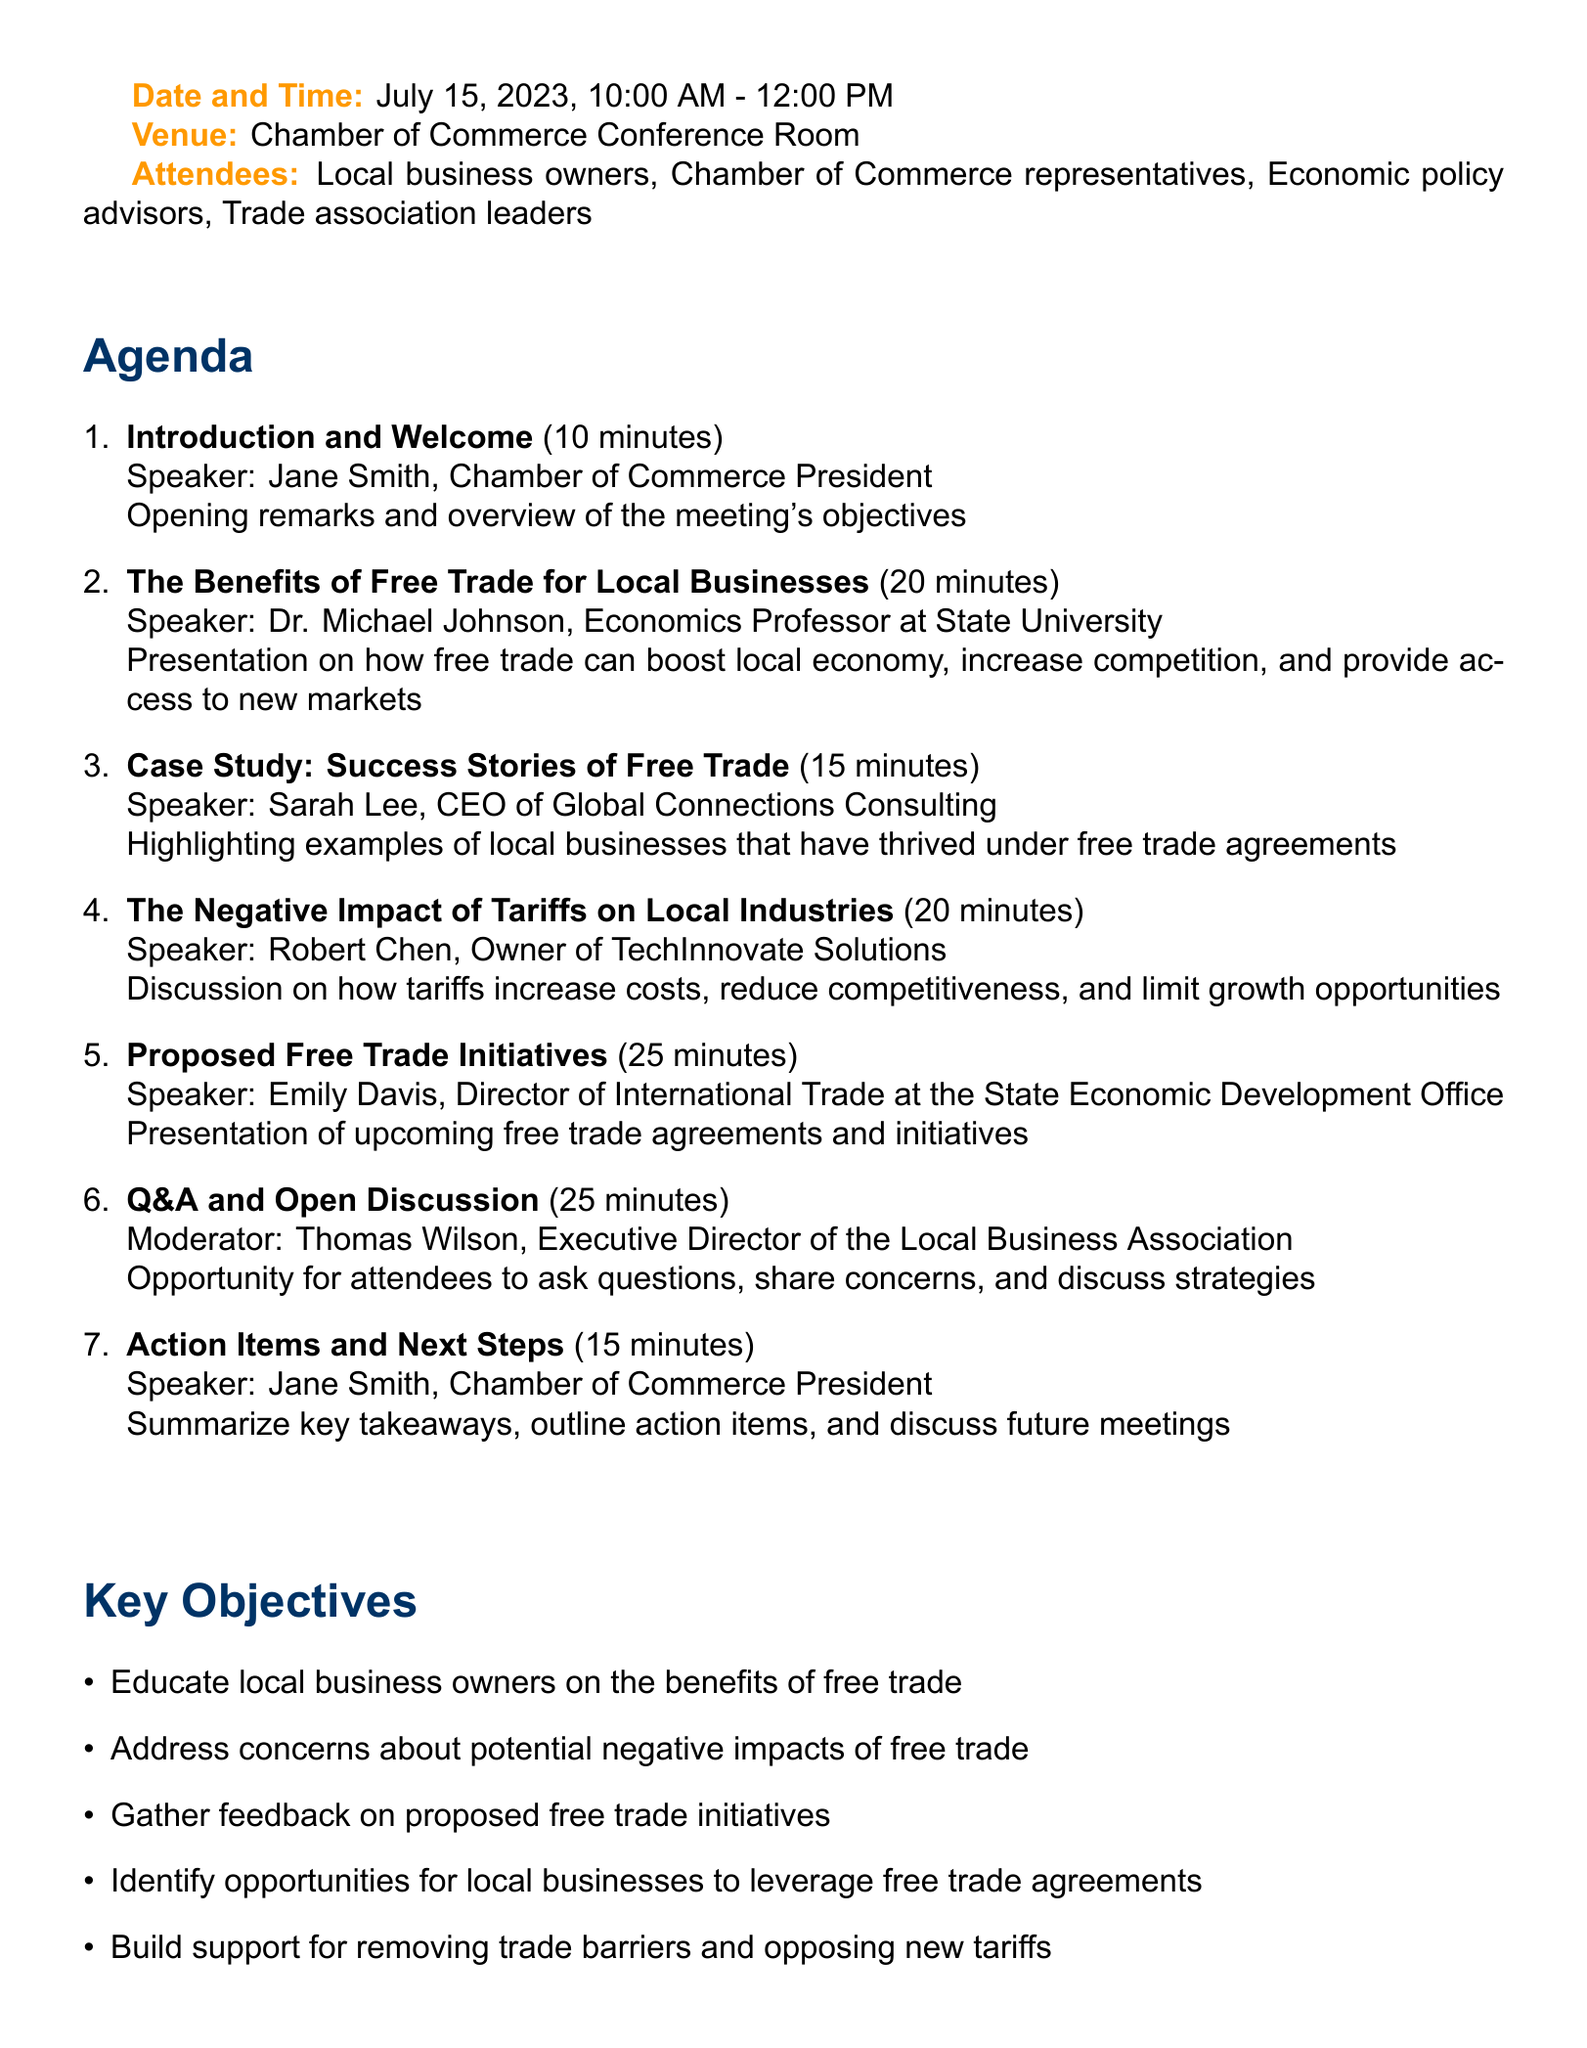What is the meeting title? The meeting title is explicitly stated at the beginning of the document.
Answer: Free Trade Initiatives: Empowering Local Businesses Who is the keynote speaker for the Benefits of Free Trade presentation? The speaker's name is listed alongside the agenda item for clarity.
Answer: Dr. Michael Johnson How long is the Q&A and Open Discussion scheduled for? The duration of this agenda item is provided clearly in the document.
Answer: 25 minutes What is one key objective mentioned in the document? The document lists several objectives, all of which support the theme of free trade.
Answer: Educate local business owners on the benefits of free trade Which organization is Jane Smith associated with? The document specifies Jane Smith's role and affiliation at the beginning of the meeting agenda.
Answer: Chamber of Commerce What is one of the supporting materials provided? The document lists several materials intended to support the discussion on free trade.
Answer: Economic impact report on free trade benefits for the local region 